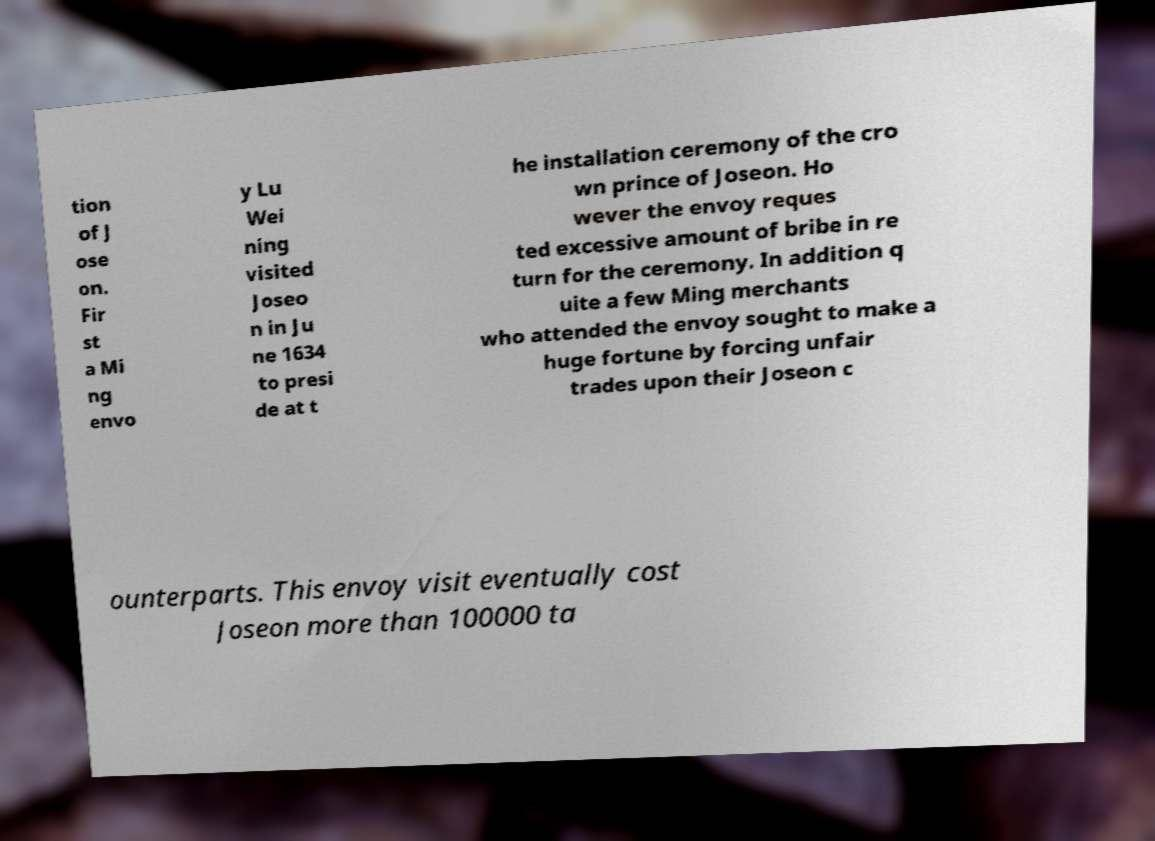I need the written content from this picture converted into text. Can you do that? tion of J ose on. Fir st a Mi ng envo y Lu Wei ning visited Joseo n in Ju ne 1634 to presi de at t he installation ceremony of the cro wn prince of Joseon. Ho wever the envoy reques ted excessive amount of bribe in re turn for the ceremony. In addition q uite a few Ming merchants who attended the envoy sought to make a huge fortune by forcing unfair trades upon their Joseon c ounterparts. This envoy visit eventually cost Joseon more than 100000 ta 